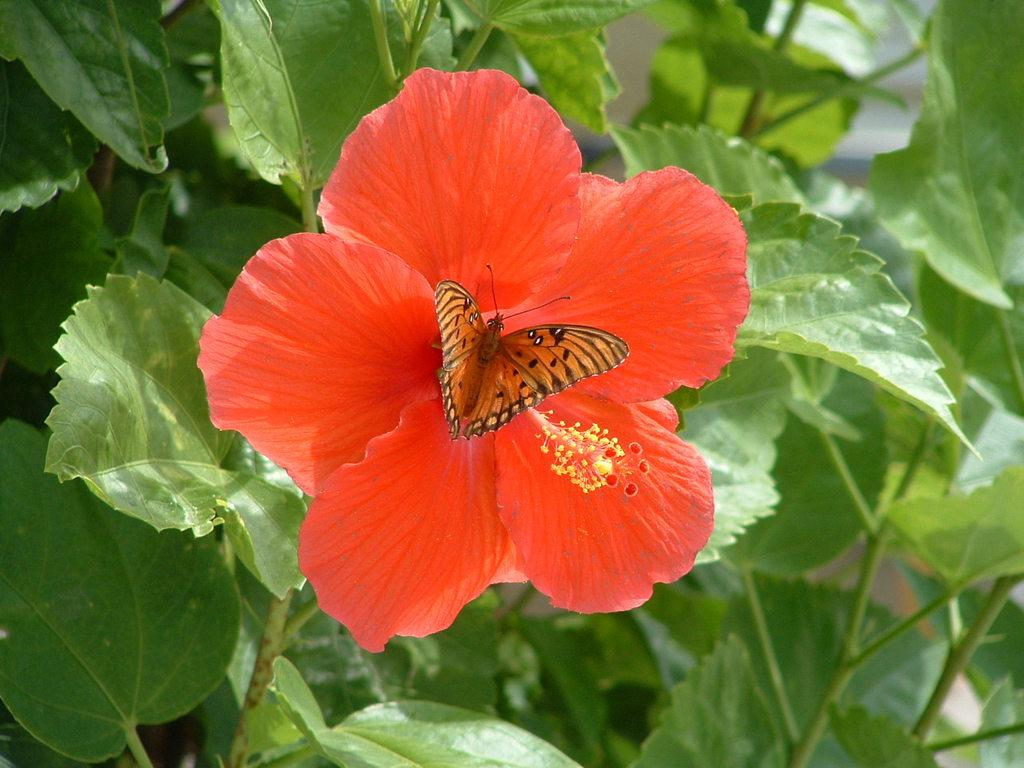What is the main subject of the image? There is a butterfly in the image. Where is the butterfly located? The butterfly is on a flower. What can be seen in the background of the image? There are leaves visible in the background of the image. What type of berry is the butterfly eating in the image? There is no berry present in the image; the butterfly is on a flower. Can you tell me who owns the property where the butterfly is located? There is no information about property ownership in the image. 